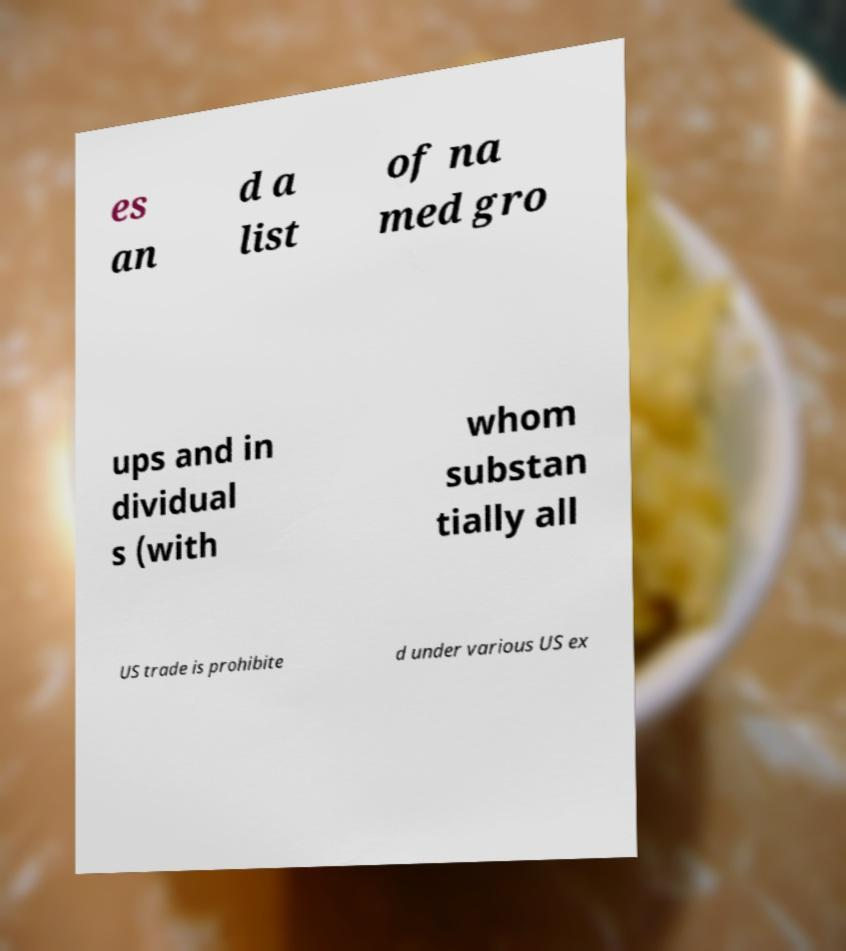What messages or text are displayed in this image? I need them in a readable, typed format. es an d a list of na med gro ups and in dividual s (with whom substan tially all US trade is prohibite d under various US ex 